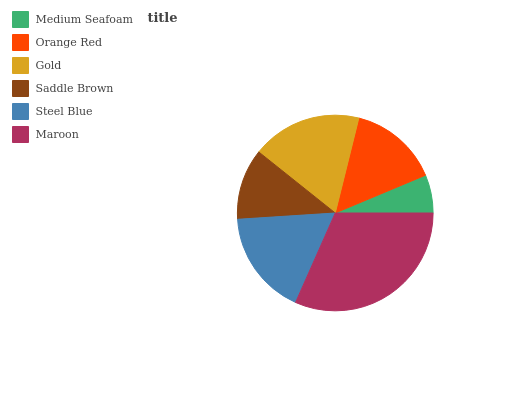Is Medium Seafoam the minimum?
Answer yes or no. Yes. Is Maroon the maximum?
Answer yes or no. Yes. Is Orange Red the minimum?
Answer yes or no. No. Is Orange Red the maximum?
Answer yes or no. No. Is Orange Red greater than Medium Seafoam?
Answer yes or no. Yes. Is Medium Seafoam less than Orange Red?
Answer yes or no. Yes. Is Medium Seafoam greater than Orange Red?
Answer yes or no. No. Is Orange Red less than Medium Seafoam?
Answer yes or no. No. Is Steel Blue the high median?
Answer yes or no. Yes. Is Orange Red the low median?
Answer yes or no. Yes. Is Saddle Brown the high median?
Answer yes or no. No. Is Gold the low median?
Answer yes or no. No. 